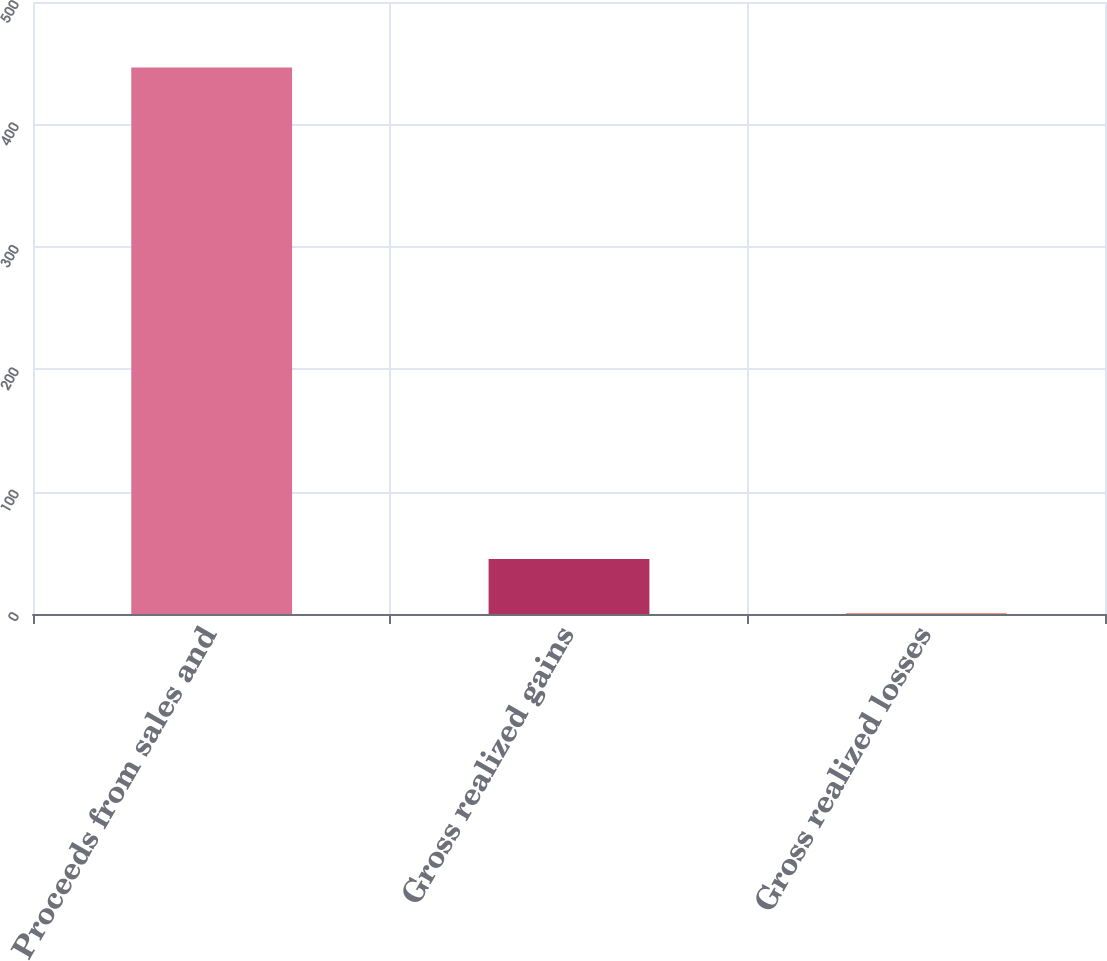<chart> <loc_0><loc_0><loc_500><loc_500><bar_chart><fcel>Proceeds from sales and<fcel>Gross realized gains<fcel>Gross realized losses<nl><fcel>446.4<fcel>45<fcel>0.4<nl></chart> 